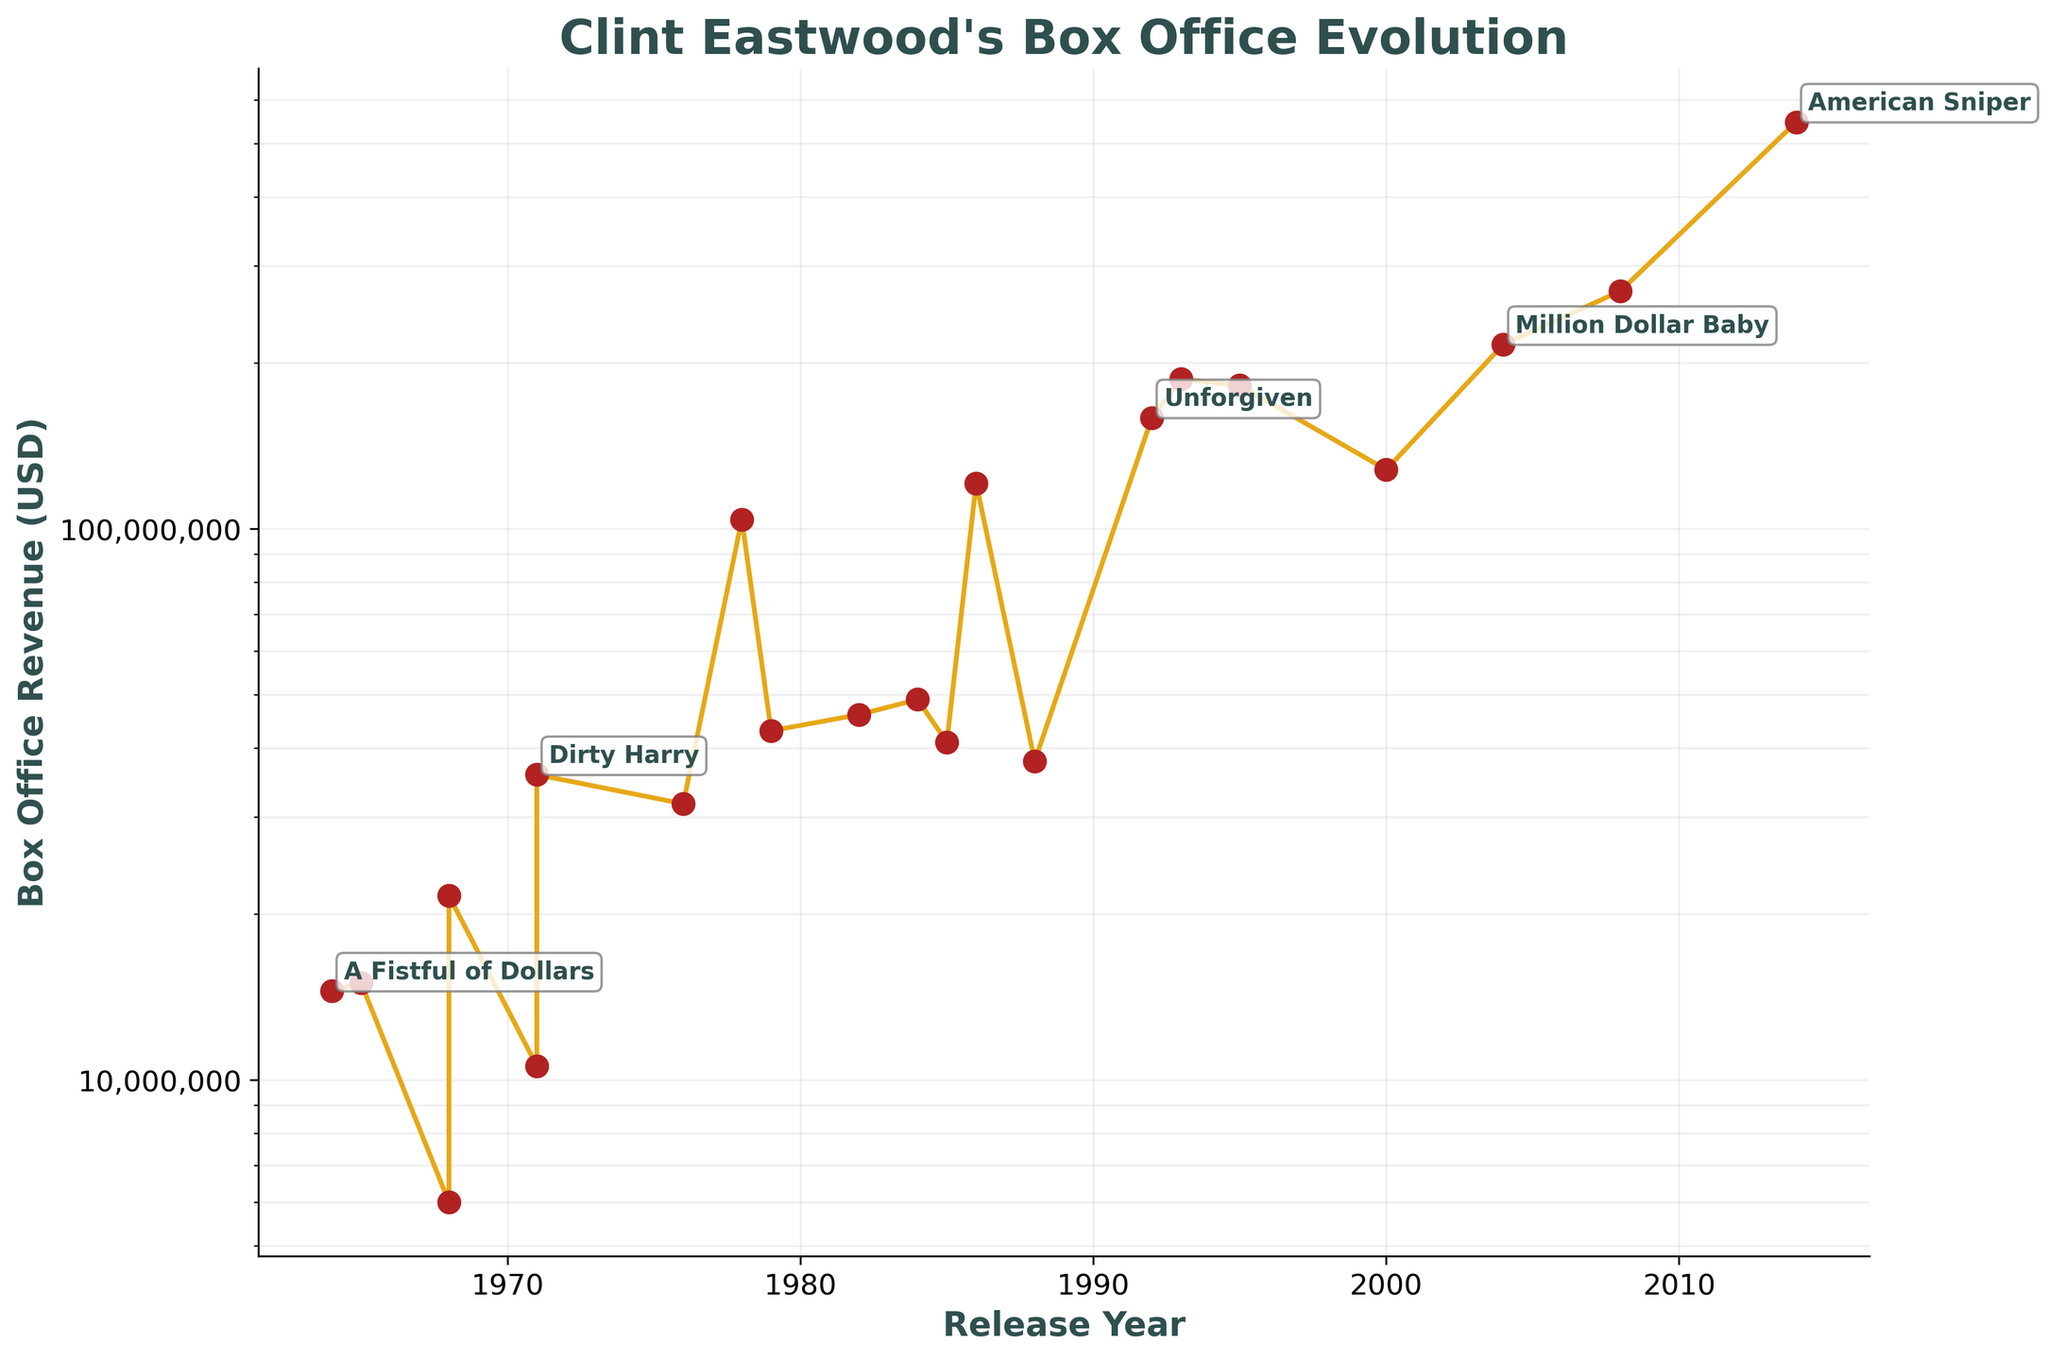What is the title of the plot? The title is generally located at the top of the plot. In this figure, it reads "Clint Eastwood's Box Office Evolution".
Answer: Clint Eastwood's Box Office Evolution What is the y-axis set to? The y-axis in the plot is set to a logarithmic scale, which means that it uses a logarithmic function to display values. This is apparent from the varying distances between tick marks on the y-axis.
Answer: Logarithmic scale Which movie was released in 2014, and what was its box office revenue? By tracing the 2014 marker on the x-axis and following the corresponding line to the y-axis, the revenue for the 2014 movie "American Sniper" can be identified as $547,000,000.
Answer: American Sniper, $547,000,000 How does the box office revenue of "Million Dollar Baby" compare to "Gran Torino"? Looking at the plot, "Million Dollar Baby" (2004) and "Gran Torino" (2008) can be compared by their y-axis positions. "Gran Torino" is positioned higher than "Million Dollar Baby," indicating a greater revenue.
Answer: Gran Torino has higher revenue What is the revenue difference between "Dirty Harry" and "Unforgiven"? From the plot, "Dirty Harry" has a revenue of $35,800,000 and "Unforgiven" has $159,000,000. The difference is calculated as $159,000,000 - $35,800,000 = $123,200,000.
Answer: $123,200,000 What trends can be observed in Clint Eastwood's movie revenues over time? Observing the entire plot, it can be noted that there is a general increasing trend over time, with notable peaks for movies like "Every Which Way But Loose," "Heartbreak Ridge," "Million Dollar Baby," and "American Sniper."
Answer: General increasing trend with notable peaks Which movie had the highest box office revenue, and in which year was it released? On the log-scaled plot, "American Sniper" reaches the highest point on the y-axis, indicating it had the highest revenue. The plot also shows that it was released in 2014.
Answer: American Sniper, 2014 How many movies have a box office revenue above $200,000,000? From the plot, movies with revenues above $200,000,000 can be counted by looking at the y-axis. These include "Million Dollar Baby" and "American Sniper," totaling two movies.
Answer: 2 movies Between 1970 and 1990, which movie had the highest box office revenue? By focusing on the x-axis range from 1970 to 1990, the plot shows that "Every Which Way But Loose" (1978) had the highest revenue, reaching up to $104,000,000.
Answer: Every Which Way But Loose What pattern is observed in the box office revenues between the 1990s and 2000s? Examining the plot, a surge in competition can be observed during the 1990s and 2000s, with significant peaks at "Unforgiven," "In the Line of Fire," "The Bridges of Madison County," and "Space Cowboys" with steadily increasing revenues
Answer: Noticeable revenue increase with peaks 